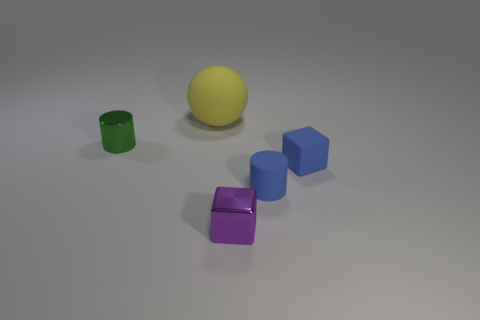What number of other big rubber things are the same shape as the big object?
Make the answer very short. 0. There is a small thing that is the same color as the matte cylinder; what is it made of?
Your response must be concise. Rubber. What number of small purple metallic blocks are there?
Your answer should be very brief. 1. Are there any red cubes made of the same material as the green cylinder?
Your answer should be very brief. No. The object that is the same color as the matte cube is what size?
Provide a succinct answer. Small. There is a metal object in front of the shiny cylinder; does it have the same size as the cylinder to the left of the tiny metal cube?
Keep it short and to the point. Yes. How big is the block that is in front of the blue matte block?
Offer a very short reply. Small. Are there any cylinders of the same color as the rubber block?
Ensure brevity in your answer.  Yes. Are there any small things to the right of the tiny cylinder to the left of the purple metal block?
Give a very brief answer. Yes. There is a blue rubber cube; is it the same size as the matte object that is behind the small blue block?
Your answer should be compact. No. 